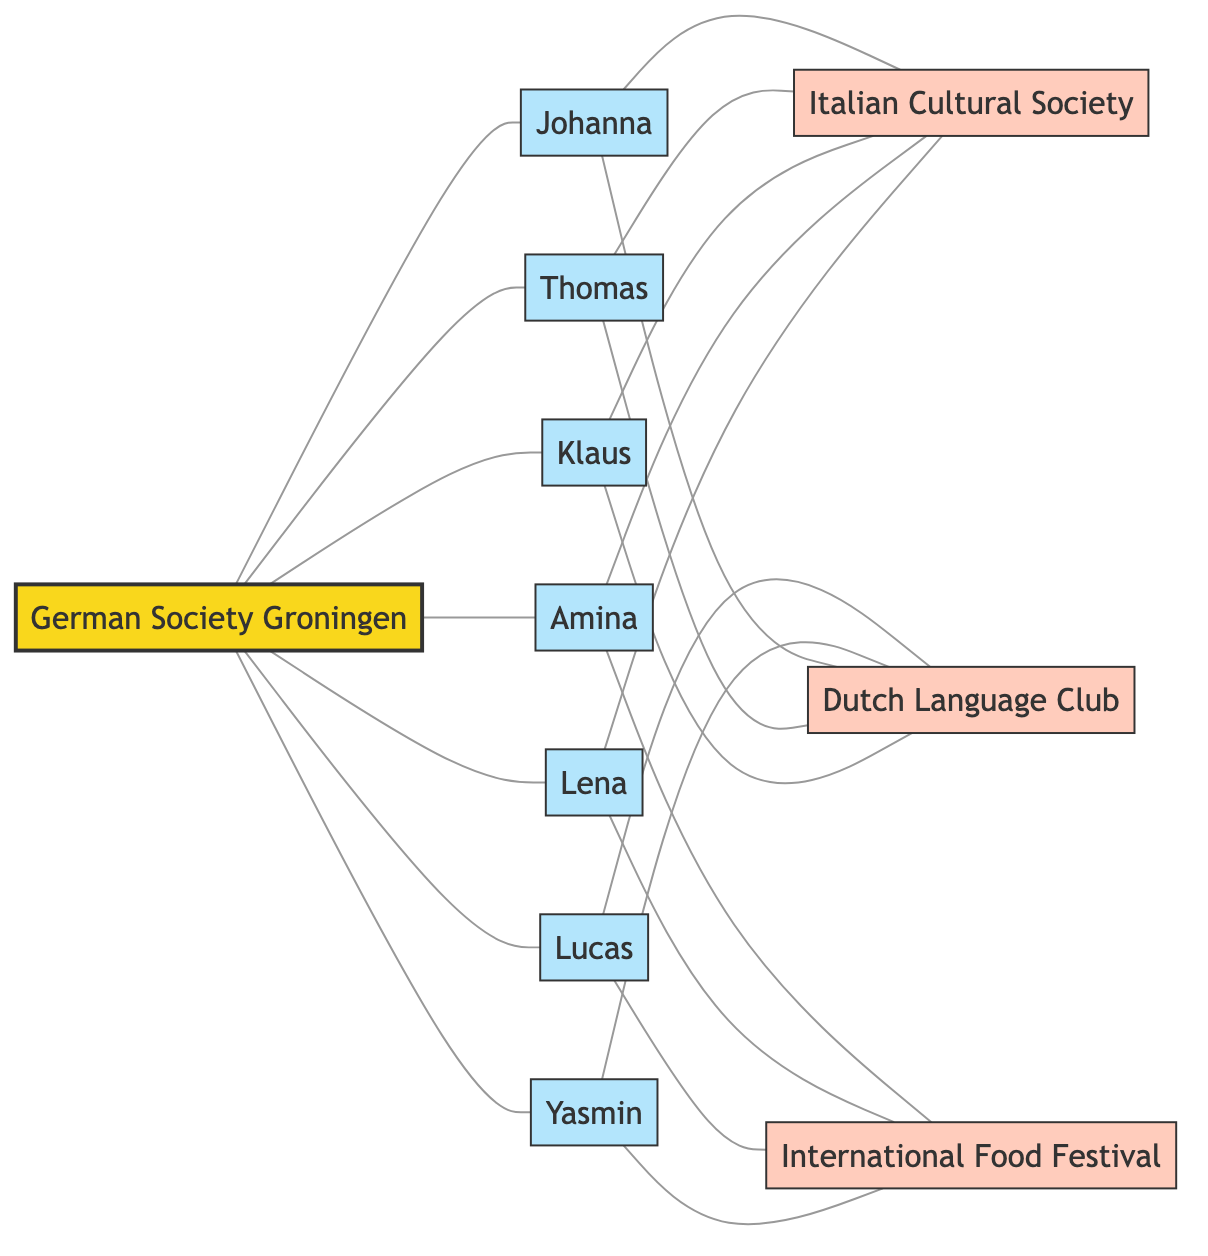What is the total number of nodes in the diagram? The diagram contains the following nodes: German Society Groningen, Johanna, Lucas, Amina, Thomas, Yasmin, Lena, Klaus, Italian Cultural Society, Dutch Language Club, and International Food Festival. Counting these, there are 11 nodes in total.
Answer: 11 How many members of the German Society Groningen are connected to the Italian Cultural Society? The members of the German Society Groningen who are connected to the Italian Cultural Society are Johanna, Thomas, and Klaus. There are three connections from these members to the Italian Cultural Society.
Answer: 3 Which member is connected to the Dutch Language Club? Looking at the edges in the diagram, both Lucas and Yasmin are connected to the Dutch Language Club. Therefore, the connection from the member to this club is established by Lucas.
Answer: Lucas How many edges connect members to the International Food Festival? The members of the German Society Groningen that connect to the International Food Festival are Amina, Lucas, Yasmin, and Lena. Therefore, there are four edges from members to the International Food Festival.
Answer: 4 Which member connects to the most external entities? By reviewing the connections of each member, it's determined that Johanna, Thomas, Lukas, and Yasmin each connects to two external entities (Italian Cultural Society and Dutch Language Club). Therefore, they all tie in connecting most to external groups.
Answer: Johanna, Thomas, Lucas, Yasmin How many total connections does Klaus have? Klaus is connected to German Society Groningen as well as the Italian Cultural Society and the Dutch Language Club. To calculate the total connections, counts are made: 1 from the society and 2 from the external entities, totaling 3 connections.
Answer: 3 What is the relationship between Yasmin and the German Society Groningen? Yasmin has a direct connection (edge) to the German Society Groningen, indicating she is a member of this society.
Answer: Member Identify the external entity connected to Amina. Examining the edges, Amina has a direct connection to the International Food Festival indicating this connection to the external entity.
Answer: International Food Festival What is the minimum number of connections any member has? After reviewing all members, Klaus has the minimum connections since he is only connected to three external entities and the German Society Groningen. Hence the smallest count of connections totals to 3 for this member.
Answer: 3 